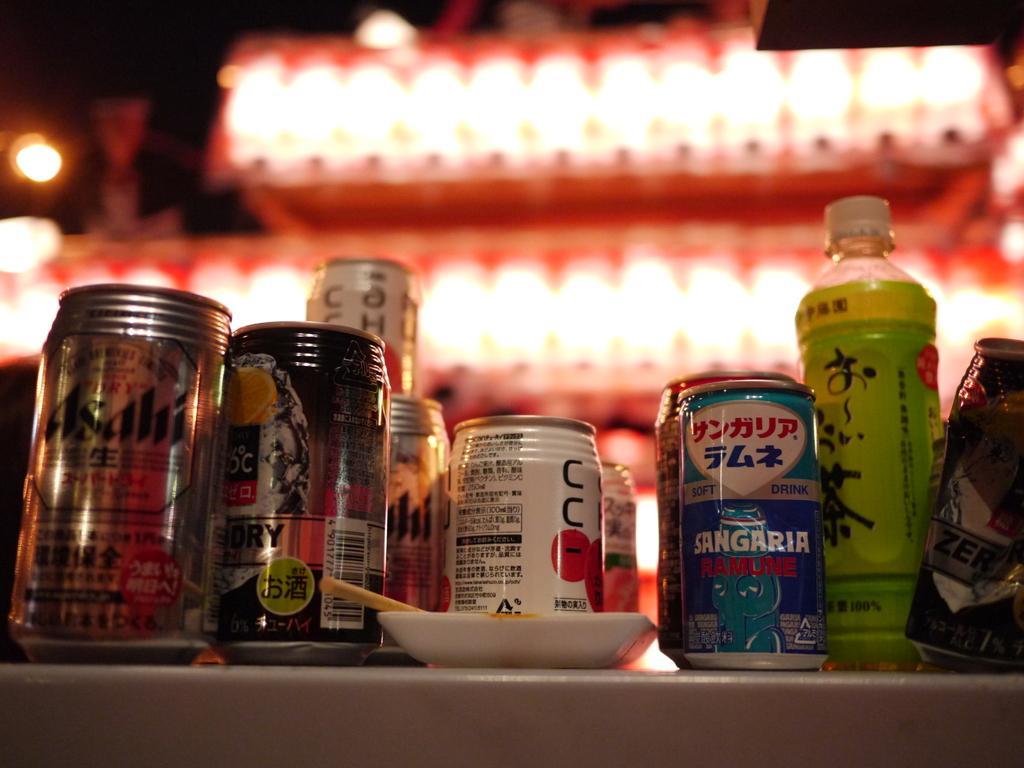How would you summarize this image in a sentence or two? There is a table. On the table, there is bottles, cans, and plate. On cans there are stickers. In the background there is light. 